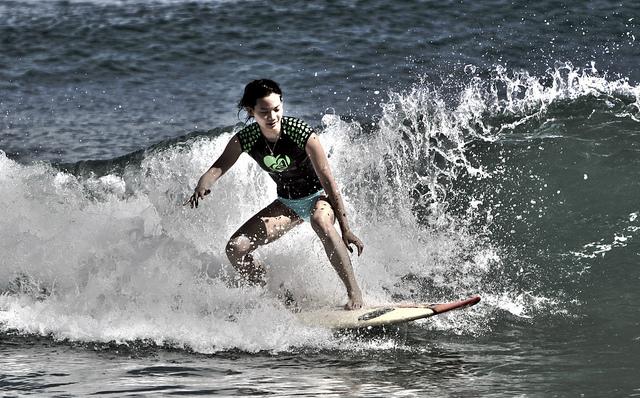What gender is the surfer?
Be succinct. Female. Is this surfer good at surfing?
Be succinct. Yes. How many feet does the surfer have?
Be succinct. 2. 